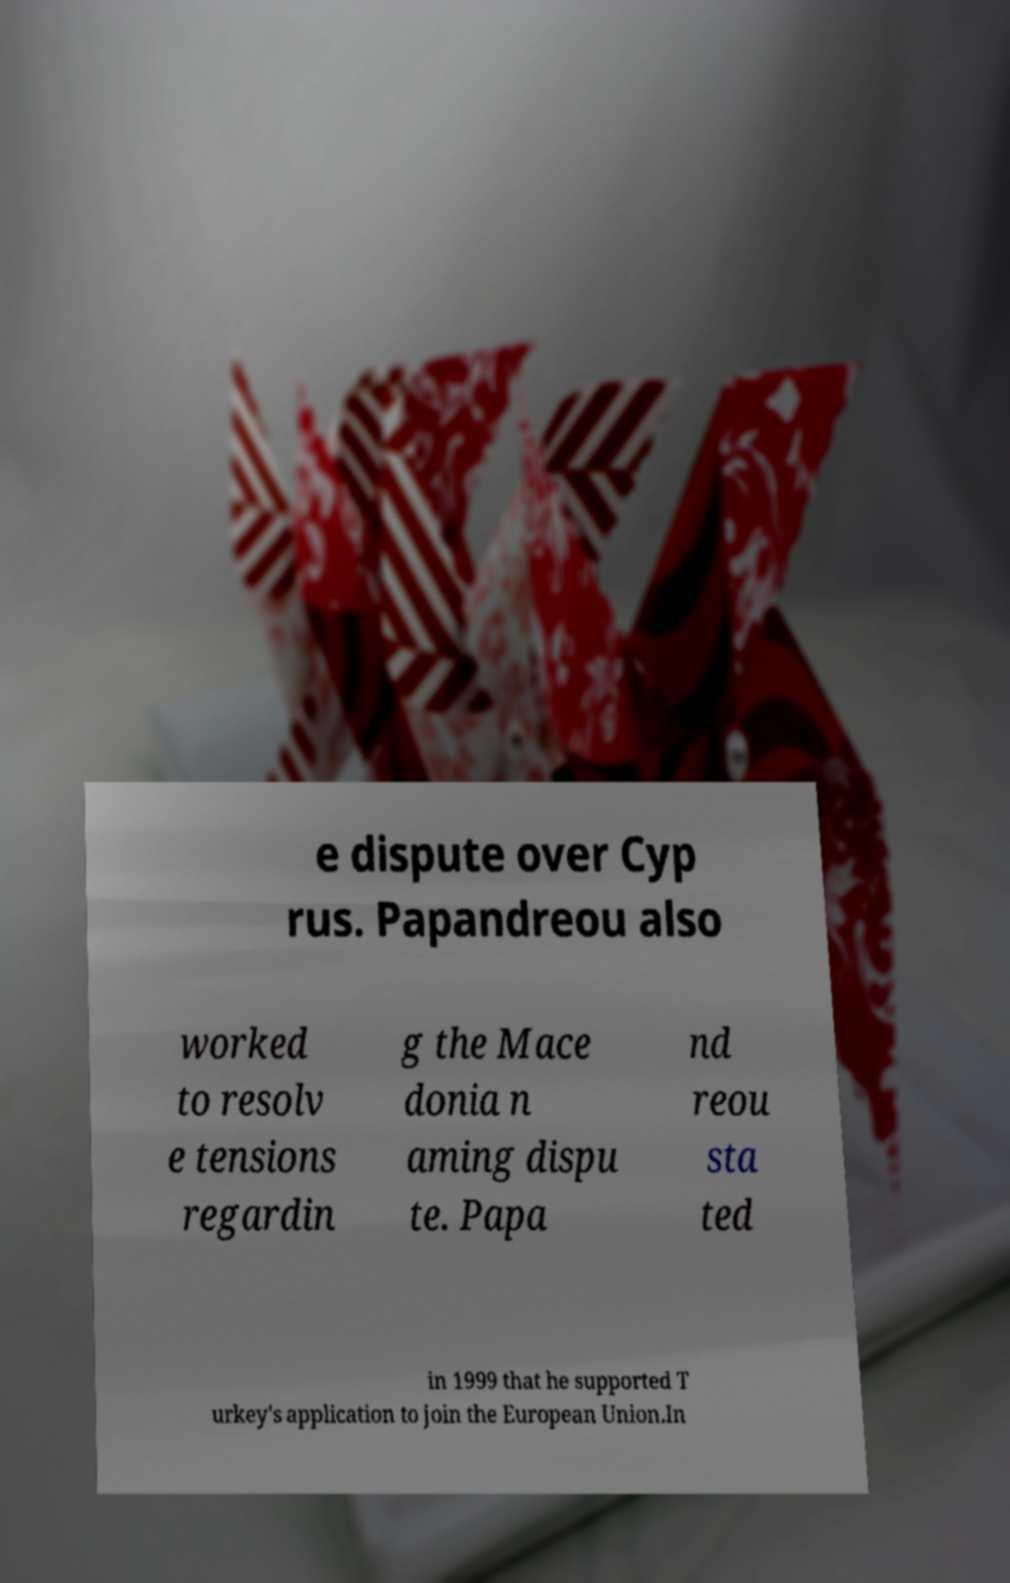Could you extract and type out the text from this image? e dispute over Cyp rus. Papandreou also worked to resolv e tensions regardin g the Mace donia n aming dispu te. Papa nd reou sta ted in 1999 that he supported T urkey's application to join the European Union.In 